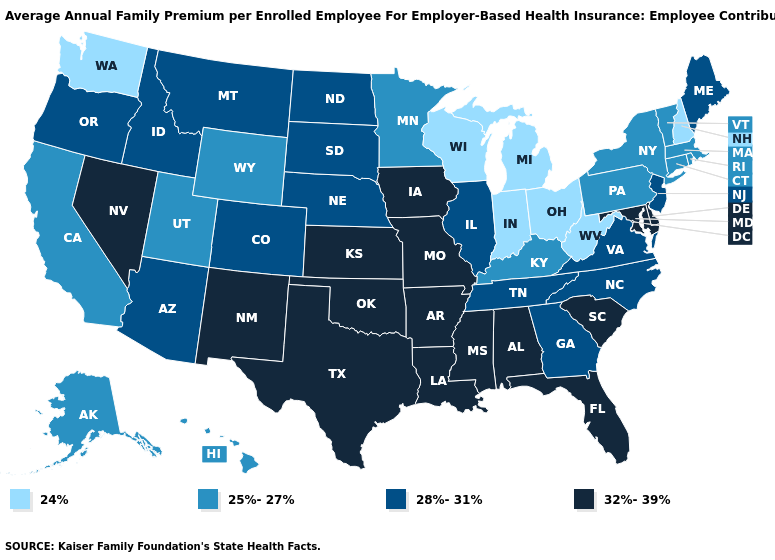Name the states that have a value in the range 25%-27%?
Give a very brief answer. Alaska, California, Connecticut, Hawaii, Kentucky, Massachusetts, Minnesota, New York, Pennsylvania, Rhode Island, Utah, Vermont, Wyoming. Does Tennessee have a higher value than Virginia?
Keep it brief. No. Which states hav the highest value in the Northeast?
Quick response, please. Maine, New Jersey. What is the value of Missouri?
Be succinct. 32%-39%. What is the highest value in the USA?
Quick response, please. 32%-39%. Which states have the highest value in the USA?
Short answer required. Alabama, Arkansas, Delaware, Florida, Iowa, Kansas, Louisiana, Maryland, Mississippi, Missouri, Nevada, New Mexico, Oklahoma, South Carolina, Texas. What is the highest value in the South ?
Be succinct. 32%-39%. Is the legend a continuous bar?
Write a very short answer. No. Among the states that border South Dakota , does Iowa have the highest value?
Keep it brief. Yes. Which states have the lowest value in the Northeast?
Short answer required. New Hampshire. Is the legend a continuous bar?
Be succinct. No. What is the value of Idaho?
Answer briefly. 28%-31%. Among the states that border New Mexico , which have the highest value?
Answer briefly. Oklahoma, Texas. What is the value of New York?
Write a very short answer. 25%-27%. What is the value of South Carolina?
Be succinct. 32%-39%. 